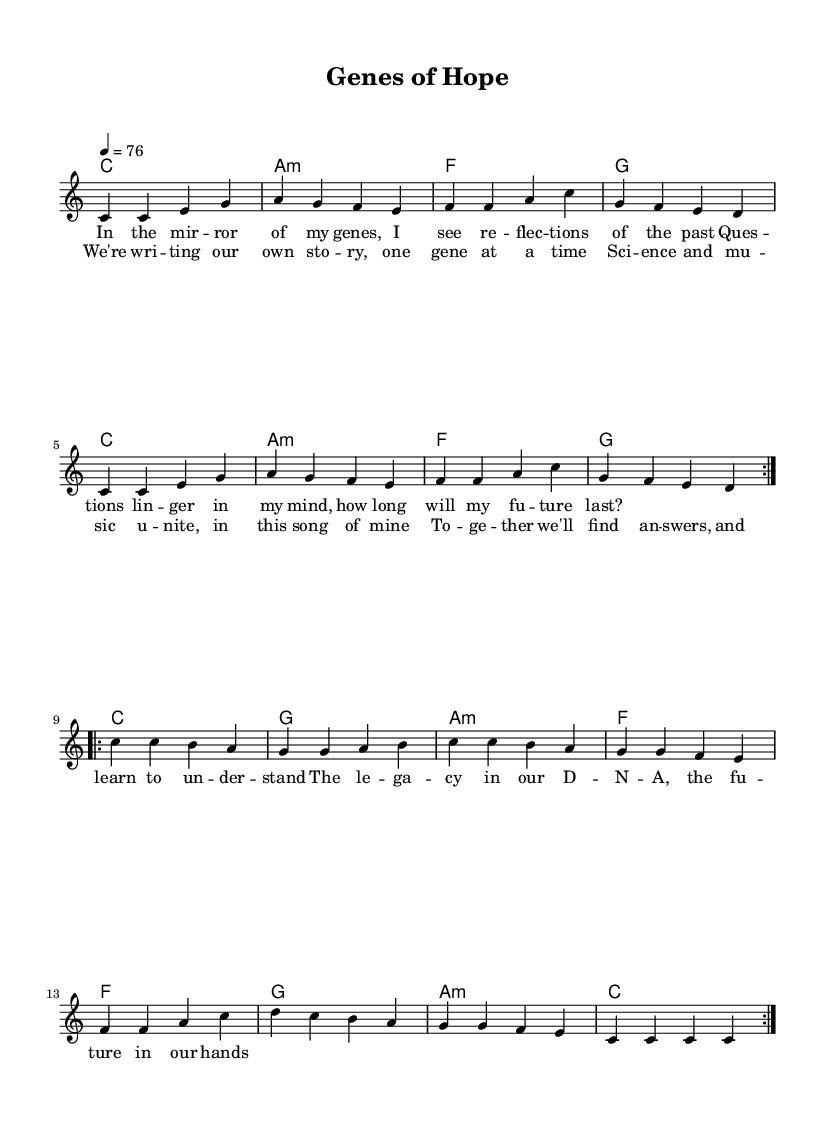What is the key signature of this music? The key signature is C major, which has no sharps or flats.
Answer: C major What is the time signature of this music? The time signature is indicated at the beginning of the score, shown as 4/4, meaning there are four beats per measure.
Answer: 4/4 What is the tempo marking for this piece? The tempo marking is noted at the beginning and is 76 beats per minute, indicating the speed at which the music should be played.
Answer: 76 How many times is the first section (volta) repeated? The first section of the melody is marked to be repeated twice (indicated by the repeat signs).
Answer: 2 What is the name of the song as indicated in the header? The title of the song is explicitly stated in the header section of the score.
Answer: Genes of Hope What is the lyric line of the chorus? The chorus lyric is written directly below the corresponding musical notes, showcasing the main theme of the song.
Answer: We're writing our own story, one gene at a time What type of collaboration does this song represent? The song exemplifies a collaboration between musicians and medical researchers to raise health awareness.
Answer: Collaboration for health awareness 